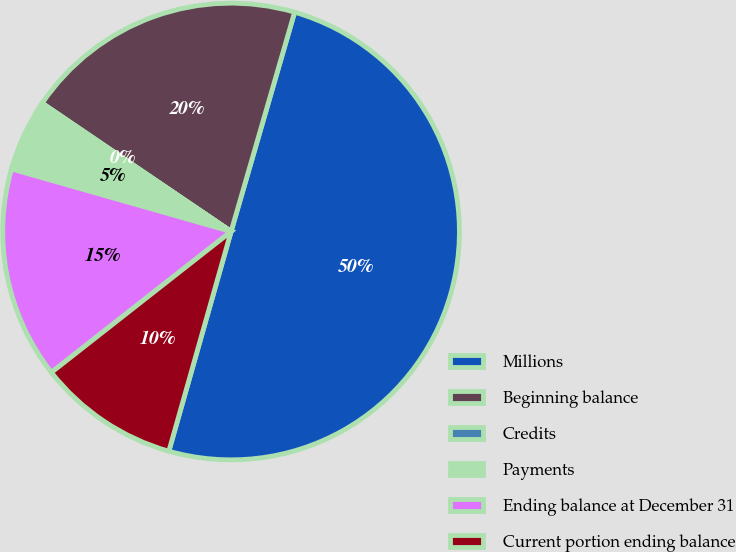Convert chart to OTSL. <chart><loc_0><loc_0><loc_500><loc_500><pie_chart><fcel>Millions<fcel>Beginning balance<fcel>Credits<fcel>Payments<fcel>Ending balance at December 31<fcel>Current portion ending balance<nl><fcel>49.9%<fcel>19.99%<fcel>0.05%<fcel>5.03%<fcel>15.0%<fcel>10.02%<nl></chart> 